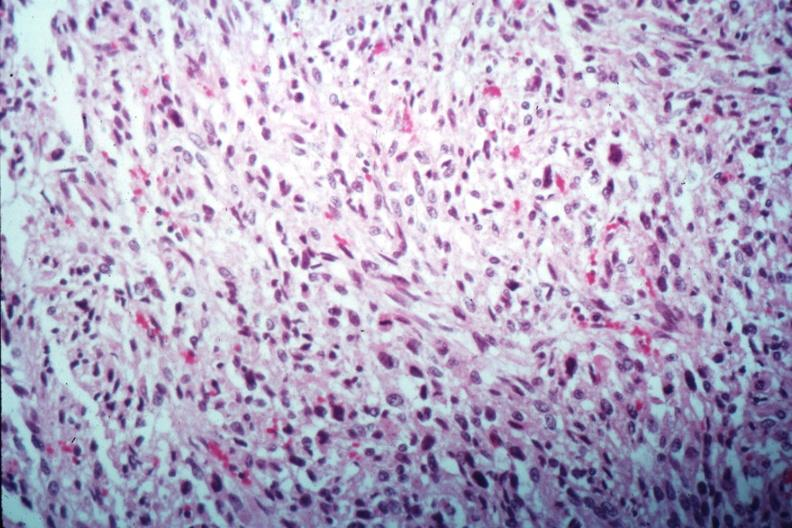what is present?
Answer the question using a single word or phrase. Female reproductive 